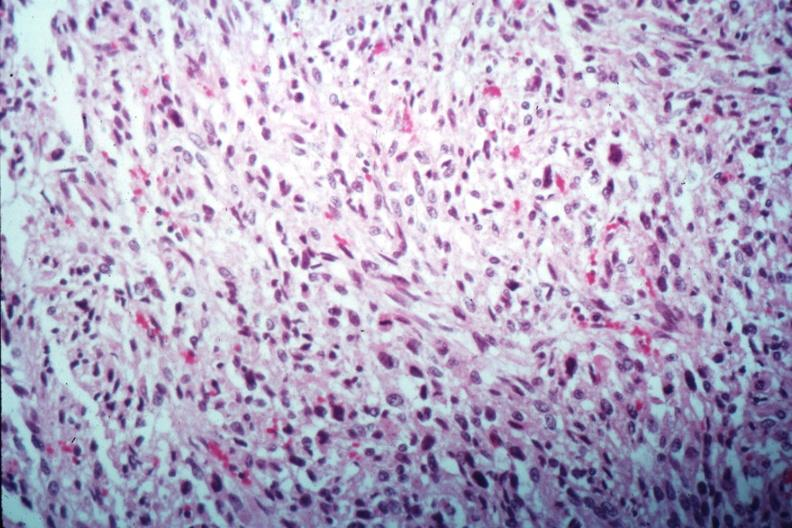what is present?
Answer the question using a single word or phrase. Female reproductive 